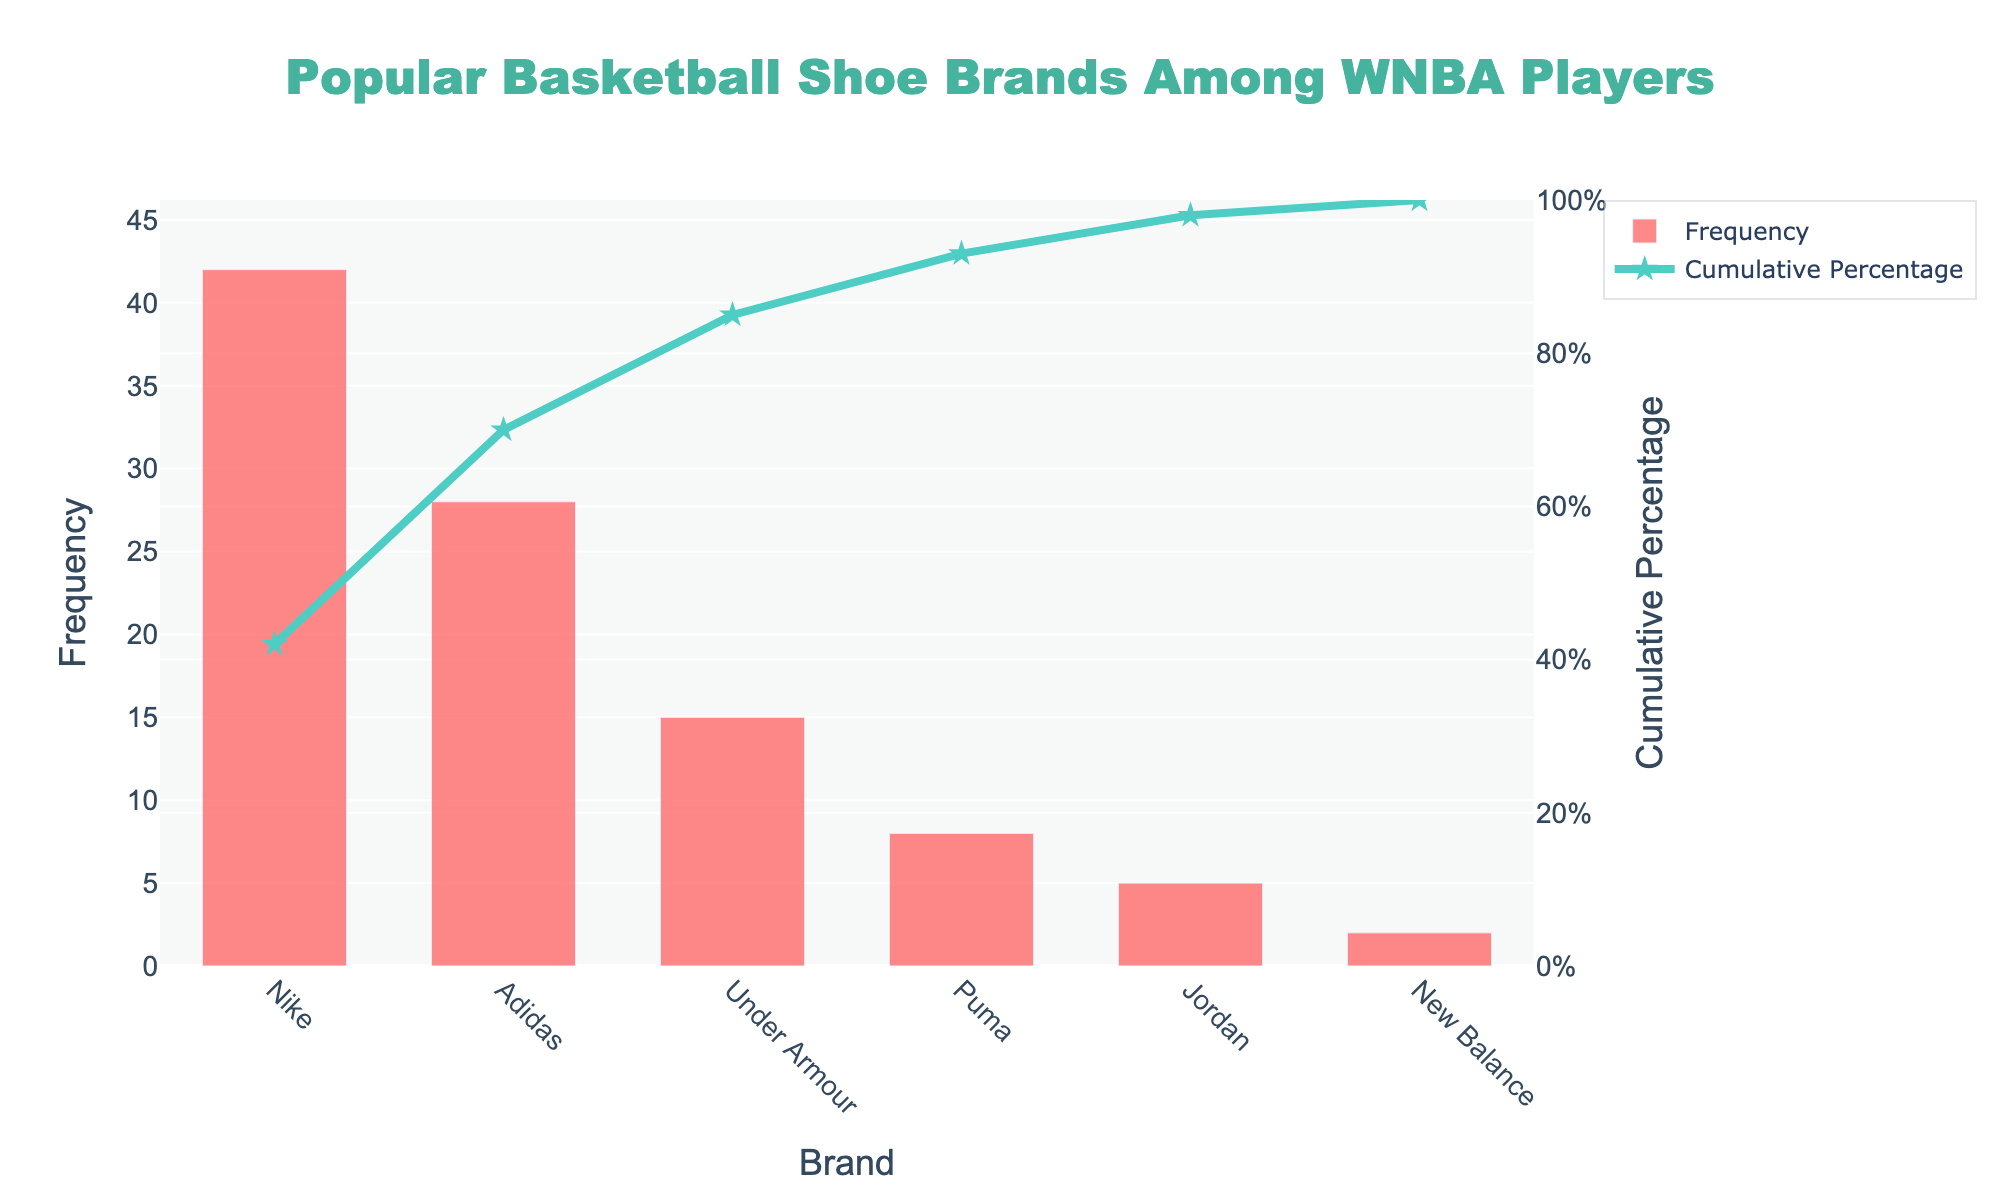what is the most popular basketball shoe brand among WNBA players? The most popular brand can be determined by looking at the bar with the highest frequency on the chart. The bar representing Nike has the highest frequency at 42.
Answer: Nike How many brands have a frequency greater than 20? To determine how many brands have a frequency greater than 20, examine each bar and count the ones that are above 20. Nike (42) and Adidas (28) meet this criterion, making a total of 2 brands.
Answer: 2 What is the cumulative percentage for Nike? The cumulative percentage for each brand is indicated by the line chart. For Nike, the corresponding cumulative percentage at the top of its bar is approximately 40%.
Answer: 40% Which brand has a cumulative percentage closest to 75%? To find the brand closest to 75% cumulative percentage, look at the points on the cumulative percentage line. The point closest to 75% is for Adidas.
Answer: Adidas By how much does Under Armour's frequency exceed Puma's? To find the difference in frequency between Under Armour and Puma, subtract Puma's frequency (8) from Under Armour's frequency (15). 15 - 8 = 7.
Answer: 7 What cumulative percentage does Jordan surpass? The cumulative percentage for Jordan is given at the point of the cumulative percentage line above its bar. This point is approximately 95%.
Answer: 95% How many brands have a frequency less than 10 but more than 2? To find brands with a frequency less than 10 but more than 2, look at each bar and count those that fall in this range. Puma (8) and Jordan (5) meet the criterion, making a total of 2 brands.
Answer: 2 What percentage of WNBA players prefer either Nike or Adidas shoes? To determine the percentage of players preferring either Nike or Adidas, sum the frequencies of Nike (42) and Adidas (28), and then divide by the total number of frequencies (42 + 28 + 15 + 8 + 5 + 2) and multiply by 100. (42 + 28) / 100 * 100 = 70%.
Answer: 70% What is the frequency of the second least popular brand? The second least popular brand can be found by arranging the frequencies in ascending order. The second least is New Balance with a frequency of 2, thus the second least would be New Balance with a frequency of 5.
Answer: Jordan 